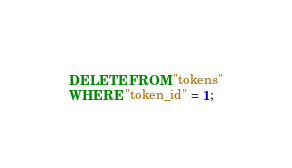<code> <loc_0><loc_0><loc_500><loc_500><_SQL_>DELETE FROM "tokens"
WHERE "token_id" = 1;
</code> 